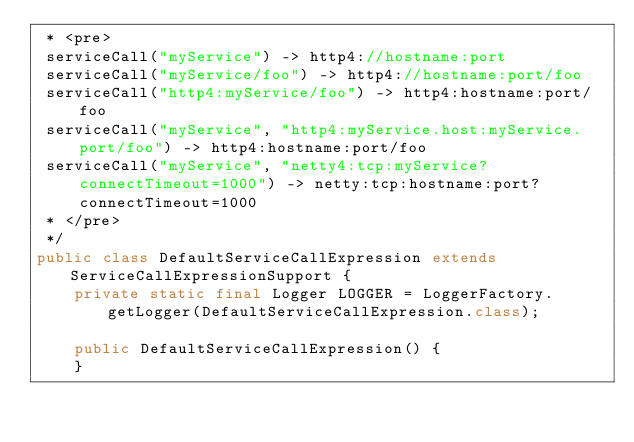Convert code to text. <code><loc_0><loc_0><loc_500><loc_500><_Java_> * <pre>
 serviceCall("myService") -> http4://hostname:port
 serviceCall("myService/foo") -> http4://hostname:port/foo
 serviceCall("http4:myService/foo") -> http4:hostname:port/foo
 serviceCall("myService", "http4:myService.host:myService.port/foo") -> http4:hostname:port/foo
 serviceCall("myService", "netty4:tcp:myService?connectTimeout=1000") -> netty:tcp:hostname:port?connectTimeout=1000
 * </pre>
 */
public class DefaultServiceCallExpression extends ServiceCallExpressionSupport {
    private static final Logger LOGGER = LoggerFactory.getLogger(DefaultServiceCallExpression.class);

    public DefaultServiceCallExpression() {
    }
</code> 